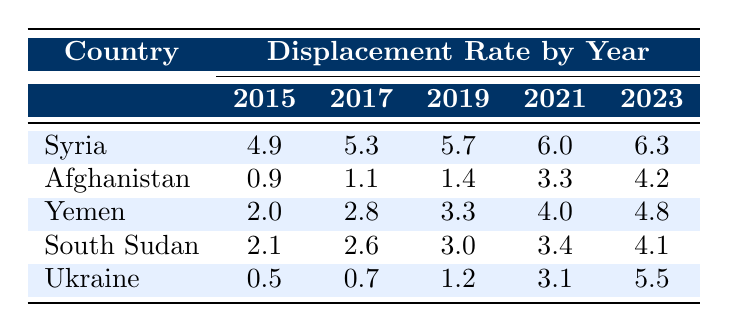What was the displacement rate in Syria in 2018? The table shows that the displacement rate for Syria in 2018 is 5.5.
Answer: 5.5 Which country had the highest displacement rate in 2023? In 2023, Syria had the highest displacement rate at 6.3.
Answer: Syria What is the difference in the displacement rate of Afghanistan between 2015 and 2023? The displacement rate in Afghanistan in 2015 is 0.9 and in 2023 is 4.2. The difference is 4.2 - 0.9 = 3.3.
Answer: 3.3 What is the average displacement rate for Yemen over the years 2015, 2017, 2019, 2021, and 2023? The displacement rates for Yemen in those years are 2.0, 2.8, 3.3, 4.0, and 4.8. Their sum is 2.0 + 2.8 + 3.3 + 4.0 + 4.8 = 16.9, and there are 5 data points, so the average is 16.9 / 5 = 3.38.
Answer: 3.38 Did the displacement rate in Ukraine increase every year from 2015 to 2023? Examining the table, the displacement rate for Ukraine increased from 0.5 in 2015 to 1.5 in 2020, then jumped to 3.1 in 2021, but then decreased to 5.5 in 2023 after a peak in 2022 at 7.0. Therefore, it did not increase every year.
Answer: No What was the trend in the displacement rates for South Sudan from 2015 to 2023? The displacement rate for South Sudan shows a consistent increase from 2.1 in 2015 to 4.1 in 2023, indicating a rising trend over the years.
Answer: Rising trend Compare the displacement rates in 2021 for both Afghanistan and South Sudan. In 2021, Afghanistan had a displacement rate of 3.3, while South Sudan had a displacement rate of 3.4. South Sudan's rate is higher by 0.1.
Answer: South Sudan's rate is higher by 0.1 Which country had the lowest displacement rate in 2019? The table shows that Ukraine had the lowest displacement rate in 2019 at 1.2, compared to the other listed countries.
Answer: Ukraine What is the total increase in displacement rate for Yemen from 2015 to 2023? The displacement rate for Yemen was 2.0 in 2015 and increased to 4.8 in 2023. The total increase is 4.8 - 2.0 = 2.8.
Answer: 2.8 What was the displacement rate for Ukraine in 2022 compared to the rate in 2023? In 2022, Ukraine had a displacement rate of 7.0, and in 2023 it decreased to 5.5, indicating a decline of 1.5.
Answer: Declined by 1.5 